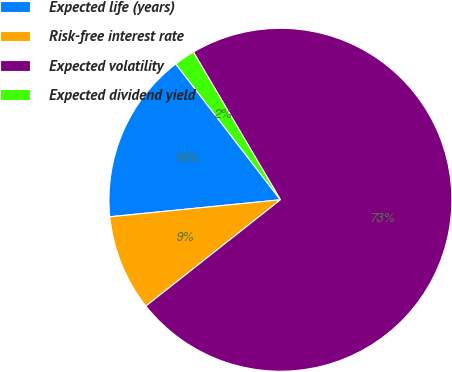<chart> <loc_0><loc_0><loc_500><loc_500><pie_chart><fcel>Expected life (years)<fcel>Risk-free interest rate<fcel>Expected volatility<fcel>Expected dividend yield<nl><fcel>16.14%<fcel>9.06%<fcel>72.83%<fcel>1.97%<nl></chart> 